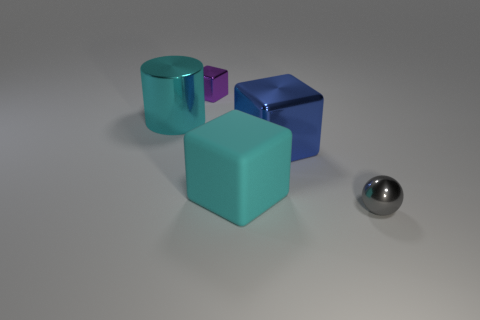Are there fewer large shiny cylinders in front of the small gray metallic sphere than small brown metal spheres?
Provide a succinct answer. No. Are there any large red shiny spheres?
Offer a very short reply. No. The other shiny thing that is the same shape as the big blue metal object is what color?
Provide a short and direct response. Purple. Does the metallic object that is to the left of the small purple object have the same color as the matte block?
Provide a succinct answer. Yes. Does the purple cube have the same size as the gray shiny object?
Ensure brevity in your answer.  Yes. What shape is the blue object that is the same material as the small gray object?
Keep it short and to the point. Cube. What number of other things are there of the same shape as the big matte thing?
Ensure brevity in your answer.  2. There is a large thing that is left of the tiny metal cube that is behind the large cyan thing in front of the big shiny cylinder; what shape is it?
Offer a terse response. Cylinder. How many spheres are tiny gray things or large cyan rubber objects?
Provide a succinct answer. 1. There is a large blue shiny object right of the purple block; is there a big blue metallic object in front of it?
Your answer should be very brief. No. 